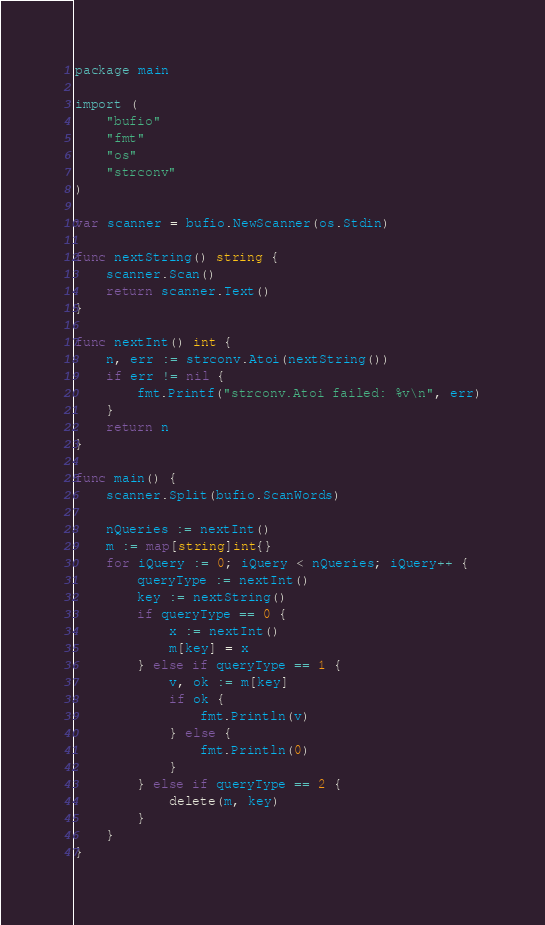<code> <loc_0><loc_0><loc_500><loc_500><_Go_>package main

import (
	"bufio"
	"fmt"
	"os"
	"strconv"
)

var scanner = bufio.NewScanner(os.Stdin)

func nextString() string {
	scanner.Scan()
	return scanner.Text()
}

func nextInt() int {
	n, err := strconv.Atoi(nextString())
	if err != nil {
		fmt.Printf("strconv.Atoi failed: %v\n", err)
	}
	return n
}

func main() {
	scanner.Split(bufio.ScanWords)

	nQueries := nextInt()
	m := map[string]int{}
	for iQuery := 0; iQuery < nQueries; iQuery++ {
		queryType := nextInt()
		key := nextString()
		if queryType == 0 {
			x := nextInt()
			m[key] = x
		} else if queryType == 1 {
			v, ok := m[key]
			if ok {
				fmt.Println(v)
			} else {
				fmt.Println(0)
			}
		} else if queryType == 2 {
			delete(m, key)
		}
	}
}

</code> 